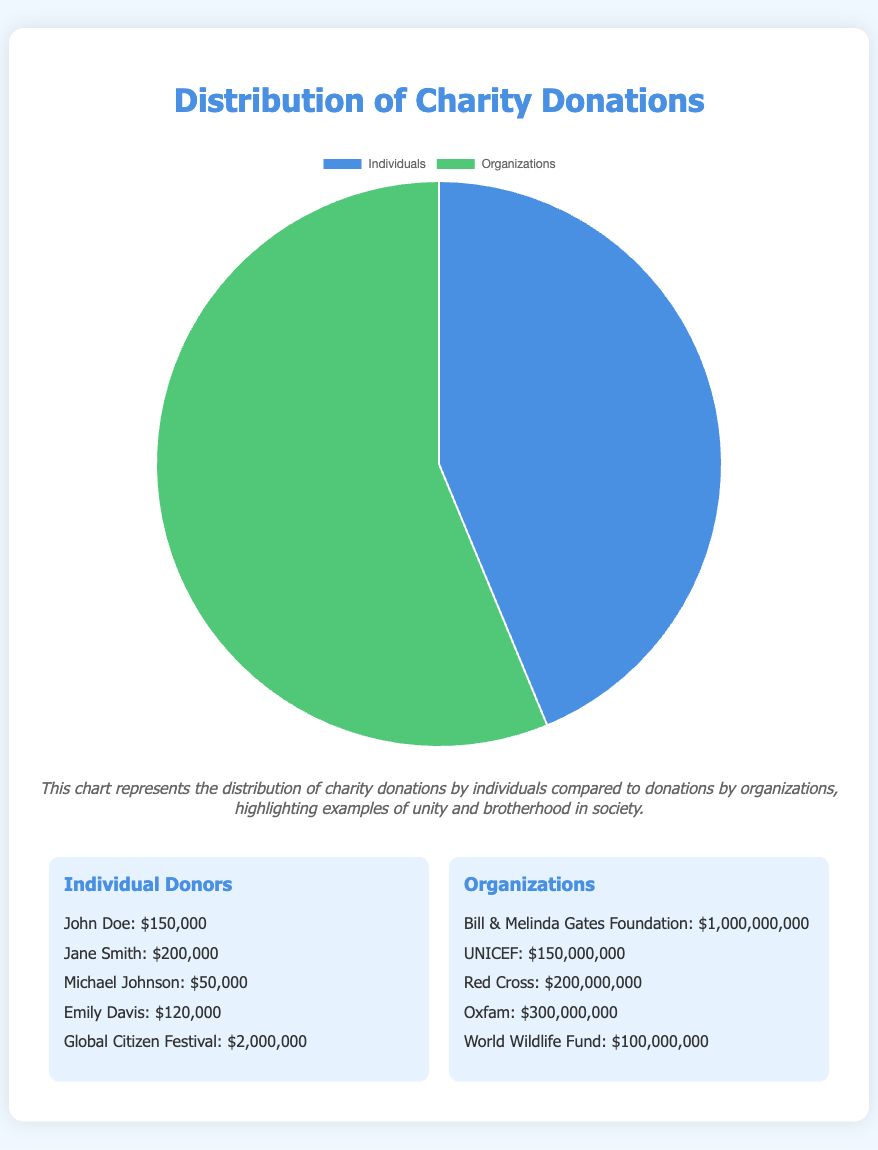How much total donation did individuals contribute? The pie chart shows the total amount of donations made by individuals, which is one of the two data points presented.
Answer: $1,750,000,000 How much more did organizations donate compared to individuals? To find out the difference in donations, subtract the total donation amount by individuals from the total donation amount by organizations: $2,250,000,000 - $1,750,000,000.
Answer: $500,000,000 What percentage of the total donations is contributed by individuals? To calculate the percentage, divide the total donation amount of individuals by the sum of donations from both individuals and organizations, then multiply by 100. This is: ($1,750,000,000 / ($1,750,000,000 + $2,250,000,000)) * 100.
Answer: 43.75% Which contributor group donated more, and by how much? Organizations donated more than individuals. The difference can be calculated as follows: $2,250,000,000 - $1,750,000,000.
Answer: Organizations, by $500,000,000 Which color represents the donations by individuals in the chart? The pie chart uses different colors to distinguish between individuals' and organizations' donations. According to the description, the color used for individuals' donations is blue.
Answer: Blue If Emily Davis donated $120,000, what is the combined donation amount of other individuals listed, excluding her contribution? Exclude Emily Davis' donation and sum the remaining donations: $150,000 + $200,000 + $50,000 + $2,000,000 = $2,400,000.
Answer: $2,400,000 